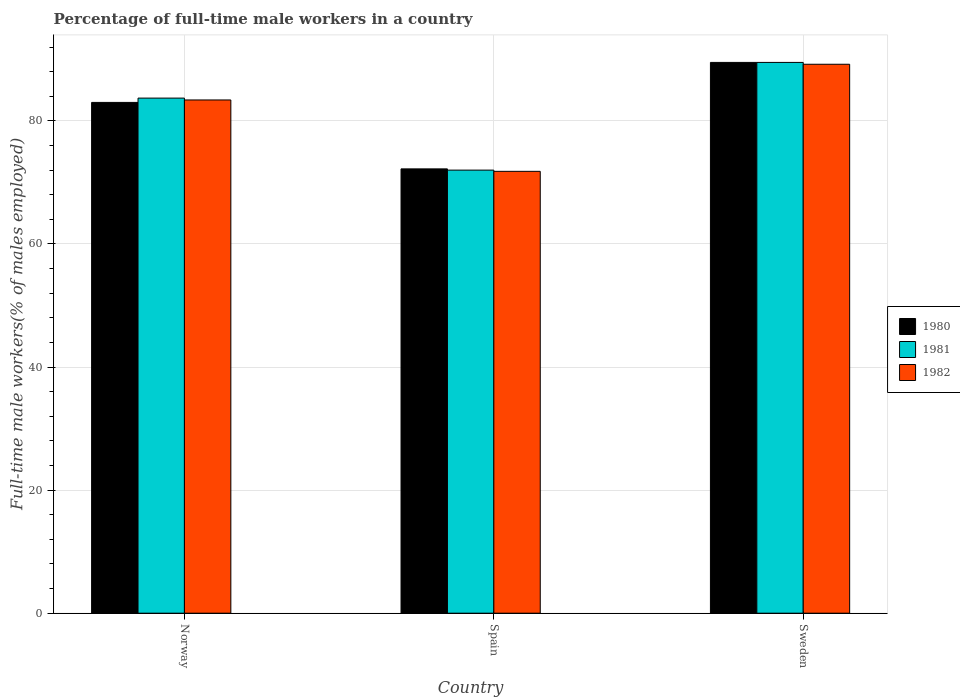How many different coloured bars are there?
Keep it short and to the point. 3. How many groups of bars are there?
Your answer should be very brief. 3. Are the number of bars per tick equal to the number of legend labels?
Your response must be concise. Yes. What is the percentage of full-time male workers in 1980 in Spain?
Your answer should be very brief. 72.2. Across all countries, what is the maximum percentage of full-time male workers in 1981?
Offer a terse response. 89.5. Across all countries, what is the minimum percentage of full-time male workers in 1982?
Your response must be concise. 71.8. In which country was the percentage of full-time male workers in 1982 maximum?
Keep it short and to the point. Sweden. In which country was the percentage of full-time male workers in 1982 minimum?
Offer a very short reply. Spain. What is the total percentage of full-time male workers in 1981 in the graph?
Ensure brevity in your answer.  245.2. What is the difference between the percentage of full-time male workers in 1980 in Norway and that in Sweden?
Your response must be concise. -6.5. What is the difference between the percentage of full-time male workers in 1981 in Sweden and the percentage of full-time male workers in 1982 in Norway?
Provide a short and direct response. 6.1. What is the average percentage of full-time male workers in 1980 per country?
Your answer should be very brief. 81.57. What is the difference between the percentage of full-time male workers of/in 1982 and percentage of full-time male workers of/in 1981 in Norway?
Offer a terse response. -0.3. In how many countries, is the percentage of full-time male workers in 1982 greater than 36 %?
Give a very brief answer. 3. What is the ratio of the percentage of full-time male workers in 1981 in Spain to that in Sweden?
Make the answer very short. 0.8. Is the difference between the percentage of full-time male workers in 1982 in Spain and Sweden greater than the difference between the percentage of full-time male workers in 1981 in Spain and Sweden?
Your answer should be very brief. Yes. What is the difference between the highest and the second highest percentage of full-time male workers in 1982?
Give a very brief answer. 5.8. What is the difference between the highest and the lowest percentage of full-time male workers in 1982?
Your answer should be very brief. 17.4. In how many countries, is the percentage of full-time male workers in 1982 greater than the average percentage of full-time male workers in 1982 taken over all countries?
Provide a succinct answer. 2. What does the 2nd bar from the left in Spain represents?
Give a very brief answer. 1981. What is the difference between two consecutive major ticks on the Y-axis?
Your answer should be very brief. 20. Are the values on the major ticks of Y-axis written in scientific E-notation?
Your answer should be compact. No. Does the graph contain any zero values?
Make the answer very short. No. Where does the legend appear in the graph?
Your response must be concise. Center right. How are the legend labels stacked?
Ensure brevity in your answer.  Vertical. What is the title of the graph?
Offer a very short reply. Percentage of full-time male workers in a country. What is the label or title of the X-axis?
Ensure brevity in your answer.  Country. What is the label or title of the Y-axis?
Give a very brief answer. Full-time male workers(% of males employed). What is the Full-time male workers(% of males employed) in 1980 in Norway?
Keep it short and to the point. 83. What is the Full-time male workers(% of males employed) in 1981 in Norway?
Ensure brevity in your answer.  83.7. What is the Full-time male workers(% of males employed) in 1982 in Norway?
Provide a short and direct response. 83.4. What is the Full-time male workers(% of males employed) of 1980 in Spain?
Your response must be concise. 72.2. What is the Full-time male workers(% of males employed) in 1982 in Spain?
Your answer should be compact. 71.8. What is the Full-time male workers(% of males employed) of 1980 in Sweden?
Give a very brief answer. 89.5. What is the Full-time male workers(% of males employed) in 1981 in Sweden?
Provide a succinct answer. 89.5. What is the Full-time male workers(% of males employed) of 1982 in Sweden?
Keep it short and to the point. 89.2. Across all countries, what is the maximum Full-time male workers(% of males employed) of 1980?
Provide a succinct answer. 89.5. Across all countries, what is the maximum Full-time male workers(% of males employed) of 1981?
Give a very brief answer. 89.5. Across all countries, what is the maximum Full-time male workers(% of males employed) in 1982?
Offer a terse response. 89.2. Across all countries, what is the minimum Full-time male workers(% of males employed) of 1980?
Your answer should be very brief. 72.2. Across all countries, what is the minimum Full-time male workers(% of males employed) of 1981?
Provide a short and direct response. 72. Across all countries, what is the minimum Full-time male workers(% of males employed) in 1982?
Make the answer very short. 71.8. What is the total Full-time male workers(% of males employed) of 1980 in the graph?
Offer a terse response. 244.7. What is the total Full-time male workers(% of males employed) of 1981 in the graph?
Make the answer very short. 245.2. What is the total Full-time male workers(% of males employed) of 1982 in the graph?
Your answer should be compact. 244.4. What is the difference between the Full-time male workers(% of males employed) in 1982 in Norway and that in Spain?
Ensure brevity in your answer.  11.6. What is the difference between the Full-time male workers(% of males employed) of 1980 in Norway and that in Sweden?
Offer a terse response. -6.5. What is the difference between the Full-time male workers(% of males employed) in 1982 in Norway and that in Sweden?
Ensure brevity in your answer.  -5.8. What is the difference between the Full-time male workers(% of males employed) of 1980 in Spain and that in Sweden?
Your answer should be compact. -17.3. What is the difference between the Full-time male workers(% of males employed) in 1981 in Spain and that in Sweden?
Provide a succinct answer. -17.5. What is the difference between the Full-time male workers(% of males employed) in 1982 in Spain and that in Sweden?
Your answer should be very brief. -17.4. What is the difference between the Full-time male workers(% of males employed) in 1980 in Norway and the Full-time male workers(% of males employed) in 1982 in Spain?
Give a very brief answer. 11.2. What is the difference between the Full-time male workers(% of males employed) of 1981 in Norway and the Full-time male workers(% of males employed) of 1982 in Spain?
Make the answer very short. 11.9. What is the difference between the Full-time male workers(% of males employed) of 1981 in Norway and the Full-time male workers(% of males employed) of 1982 in Sweden?
Give a very brief answer. -5.5. What is the difference between the Full-time male workers(% of males employed) in 1980 in Spain and the Full-time male workers(% of males employed) in 1981 in Sweden?
Offer a very short reply. -17.3. What is the difference between the Full-time male workers(% of males employed) of 1980 in Spain and the Full-time male workers(% of males employed) of 1982 in Sweden?
Keep it short and to the point. -17. What is the difference between the Full-time male workers(% of males employed) in 1981 in Spain and the Full-time male workers(% of males employed) in 1982 in Sweden?
Keep it short and to the point. -17.2. What is the average Full-time male workers(% of males employed) of 1980 per country?
Provide a short and direct response. 81.57. What is the average Full-time male workers(% of males employed) of 1981 per country?
Offer a very short reply. 81.73. What is the average Full-time male workers(% of males employed) of 1982 per country?
Ensure brevity in your answer.  81.47. What is the difference between the Full-time male workers(% of males employed) of 1980 and Full-time male workers(% of males employed) of 1982 in Norway?
Your answer should be very brief. -0.4. What is the difference between the Full-time male workers(% of males employed) in 1980 and Full-time male workers(% of males employed) in 1981 in Spain?
Give a very brief answer. 0.2. What is the difference between the Full-time male workers(% of males employed) in 1980 and Full-time male workers(% of males employed) in 1982 in Spain?
Your answer should be very brief. 0.4. What is the difference between the Full-time male workers(% of males employed) of 1981 and Full-time male workers(% of males employed) of 1982 in Spain?
Give a very brief answer. 0.2. What is the difference between the Full-time male workers(% of males employed) of 1980 and Full-time male workers(% of males employed) of 1981 in Sweden?
Your response must be concise. 0. What is the difference between the Full-time male workers(% of males employed) in 1980 and Full-time male workers(% of males employed) in 1982 in Sweden?
Ensure brevity in your answer.  0.3. What is the ratio of the Full-time male workers(% of males employed) in 1980 in Norway to that in Spain?
Your answer should be compact. 1.15. What is the ratio of the Full-time male workers(% of males employed) in 1981 in Norway to that in Spain?
Make the answer very short. 1.16. What is the ratio of the Full-time male workers(% of males employed) of 1982 in Norway to that in Spain?
Offer a very short reply. 1.16. What is the ratio of the Full-time male workers(% of males employed) of 1980 in Norway to that in Sweden?
Provide a short and direct response. 0.93. What is the ratio of the Full-time male workers(% of males employed) of 1981 in Norway to that in Sweden?
Your answer should be compact. 0.94. What is the ratio of the Full-time male workers(% of males employed) in 1982 in Norway to that in Sweden?
Provide a short and direct response. 0.94. What is the ratio of the Full-time male workers(% of males employed) of 1980 in Spain to that in Sweden?
Offer a very short reply. 0.81. What is the ratio of the Full-time male workers(% of males employed) in 1981 in Spain to that in Sweden?
Keep it short and to the point. 0.8. What is the ratio of the Full-time male workers(% of males employed) in 1982 in Spain to that in Sweden?
Ensure brevity in your answer.  0.8. What is the difference between the highest and the second highest Full-time male workers(% of males employed) of 1980?
Ensure brevity in your answer.  6.5. What is the difference between the highest and the second highest Full-time male workers(% of males employed) of 1981?
Ensure brevity in your answer.  5.8. What is the difference between the highest and the second highest Full-time male workers(% of males employed) in 1982?
Your response must be concise. 5.8. What is the difference between the highest and the lowest Full-time male workers(% of males employed) in 1980?
Your answer should be very brief. 17.3. 